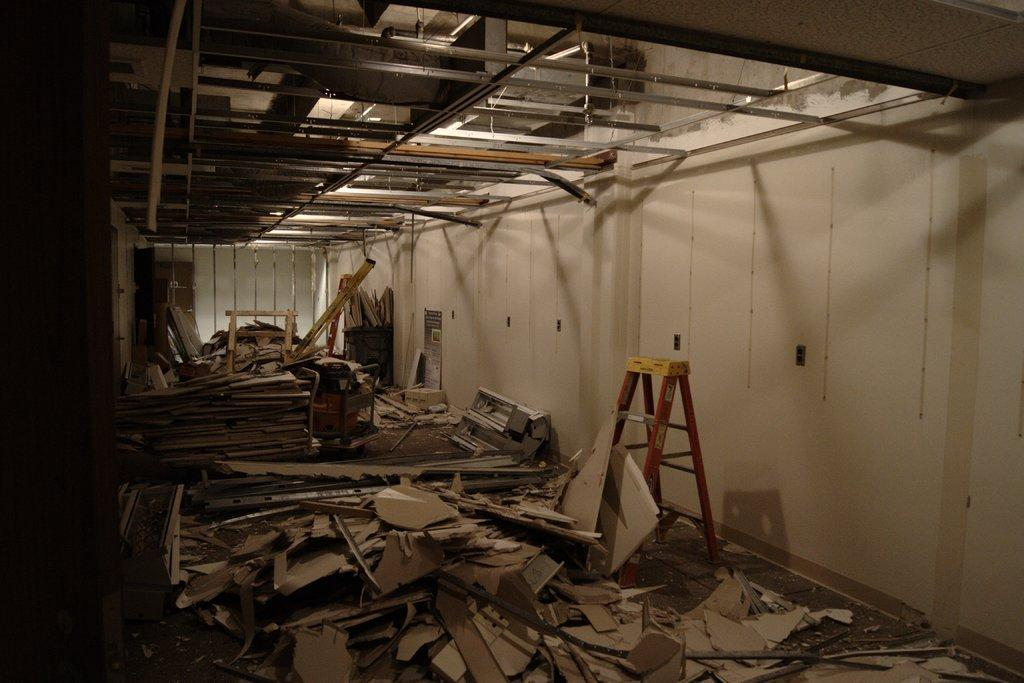What type of structures can be seen in the image? There are walls in the image. What is used for climbing or reaching higher levels in the image? There is a ladder in the image. What are the long, thin vertical structures in the image? There are poles in the image. Can you describe the unspecified objects in the image? Unfortunately, the facts provided do not give any details about the unspecified objects in the image. How does the quicksand affect the walls in the image? There is no quicksand present in the image, so it does not affect the walls. Can you provide an example of an unspecified object in the image? Unfortunately, the facts provided do not give any details about the unspecified objects in the image, so it is impossible to provide an example. 